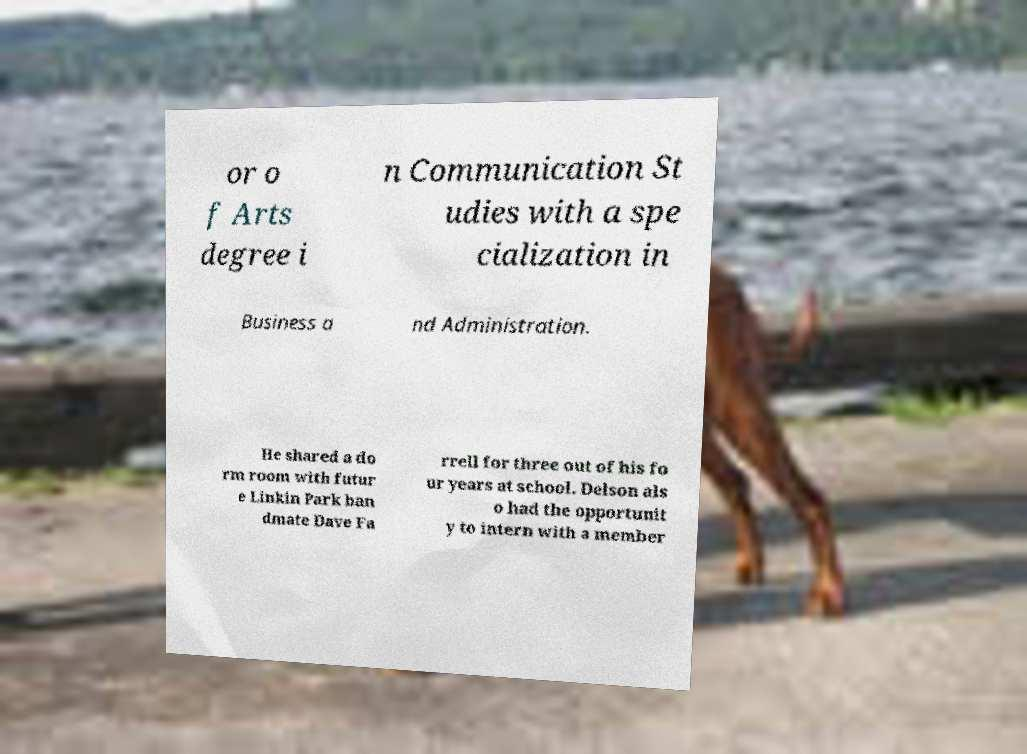What messages or text are displayed in this image? I need them in a readable, typed format. or o f Arts degree i n Communication St udies with a spe cialization in Business a nd Administration. He shared a do rm room with futur e Linkin Park ban dmate Dave Fa rrell for three out of his fo ur years at school. Delson als o had the opportunit y to intern with a member 